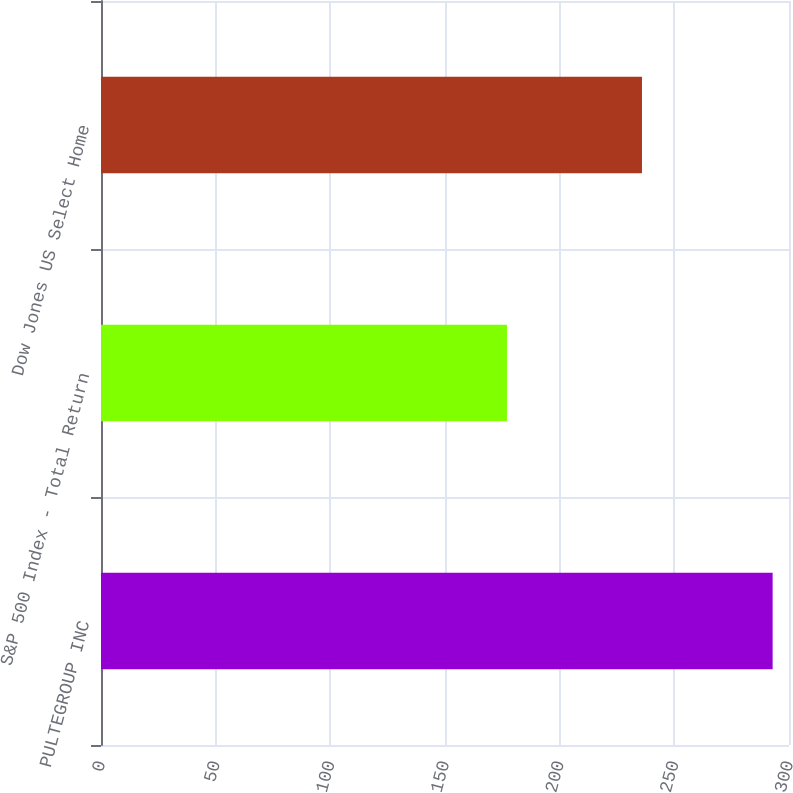Convert chart to OTSL. <chart><loc_0><loc_0><loc_500><loc_500><bar_chart><fcel>PULTEGROUP INC<fcel>S&P 500 Index - Total Return<fcel>Dow Jones US Select Home<nl><fcel>292.86<fcel>177.01<fcel>235.89<nl></chart> 